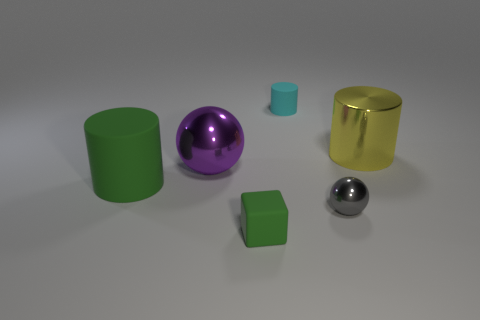Do the purple sphere and the block have the same size?
Offer a terse response. No. What number of things are the same color as the small block?
Keep it short and to the point. 1. There is a block that is the same color as the big matte cylinder; what is its material?
Keep it short and to the point. Rubber. There is a green rubber object in front of the green thing to the left of the small matte thing that is in front of the large metallic cylinder; how big is it?
Make the answer very short. Small. Are there any purple spheres on the right side of the rubber cylinder that is behind the big yellow object?
Offer a very short reply. No. Do the gray thing and the large shiny object to the left of the tiny green cube have the same shape?
Ensure brevity in your answer.  Yes. What color is the cylinder in front of the big yellow metal object?
Your answer should be compact. Green. There is a green rubber object that is in front of the green rubber object behind the small gray thing; what size is it?
Provide a succinct answer. Small. There is a rubber thing behind the big green matte cylinder; is its shape the same as the small green rubber object?
Your answer should be very brief. No. There is another object that is the same shape as the big purple metal object; what is its material?
Give a very brief answer. Metal. 